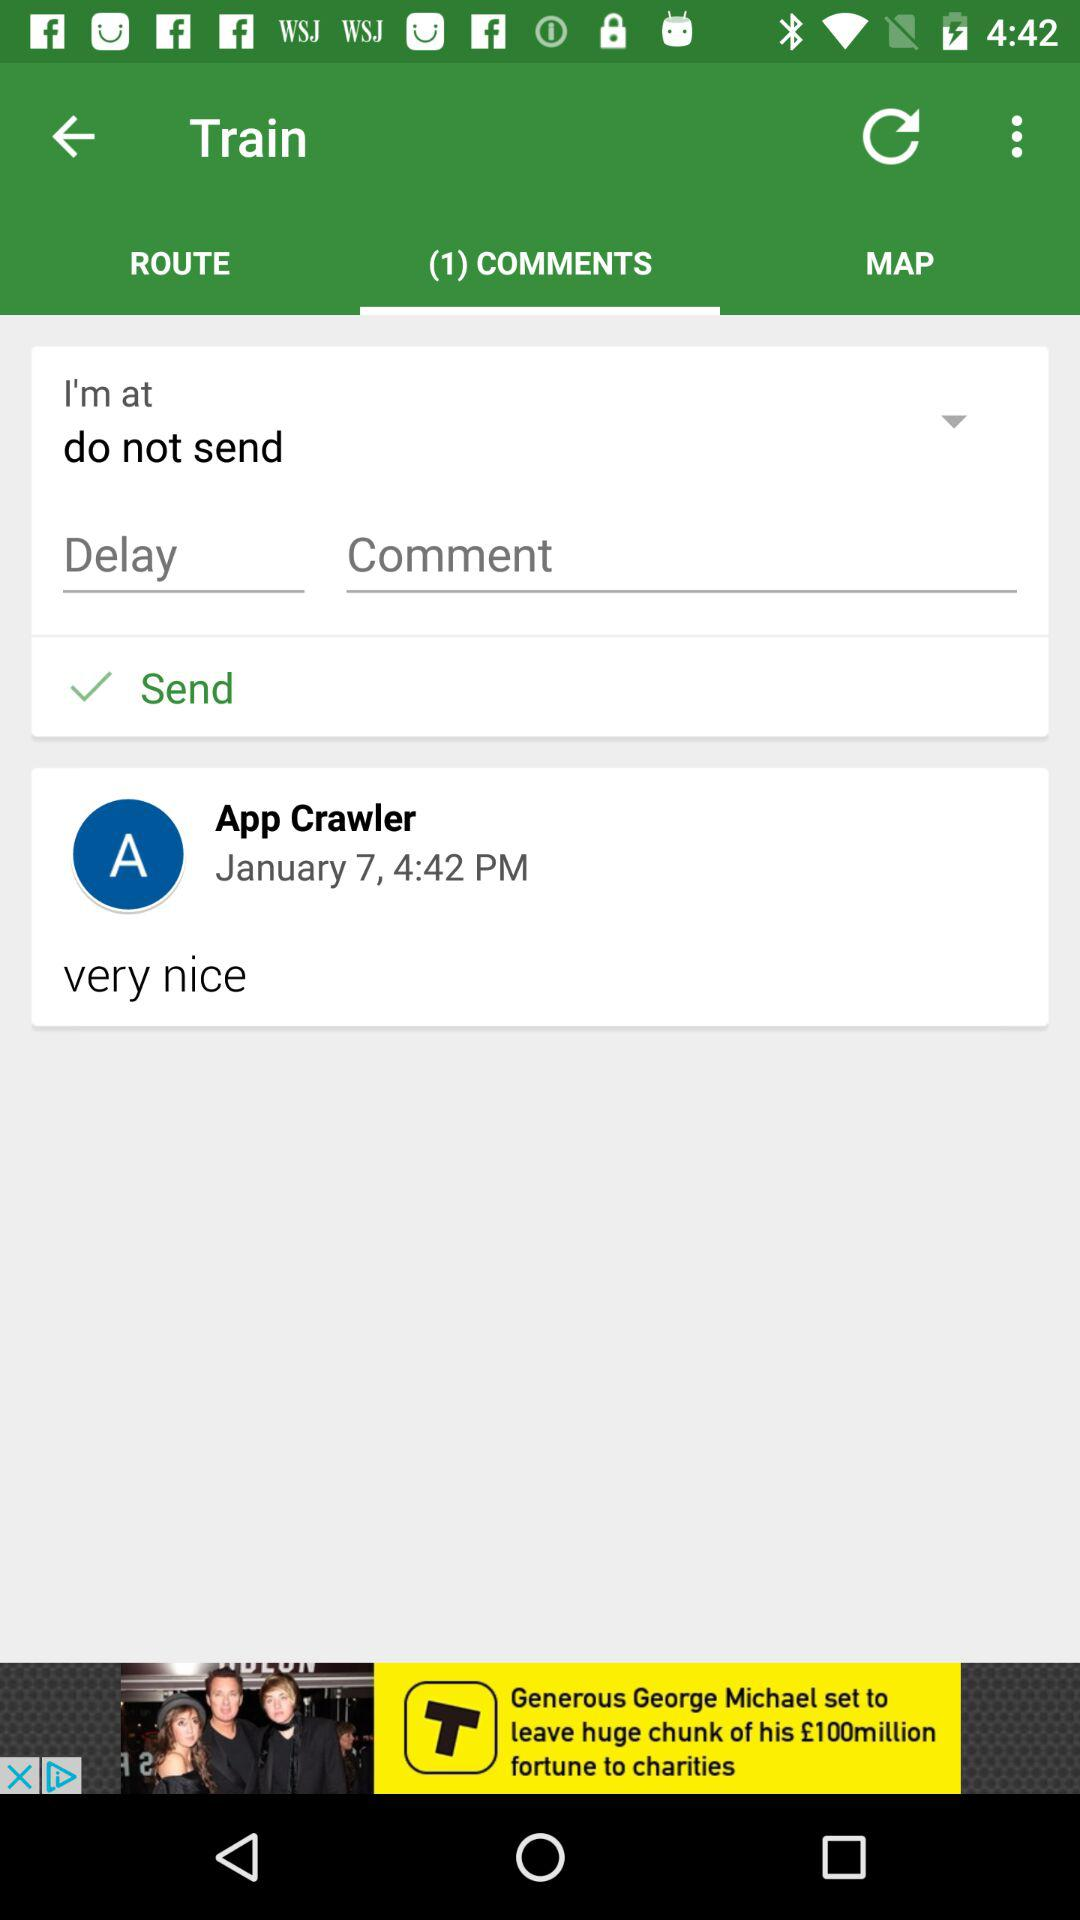Which tab has been selected? The tab that has been selected is "(1) COMMENTS". 